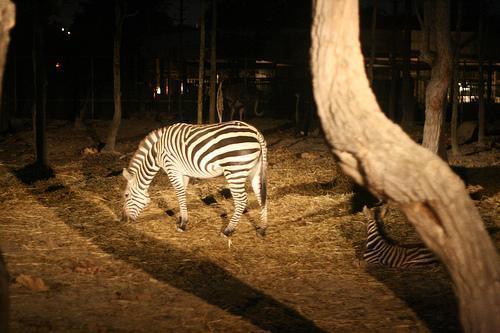How many animals are shown?
Give a very brief answer. 2. 